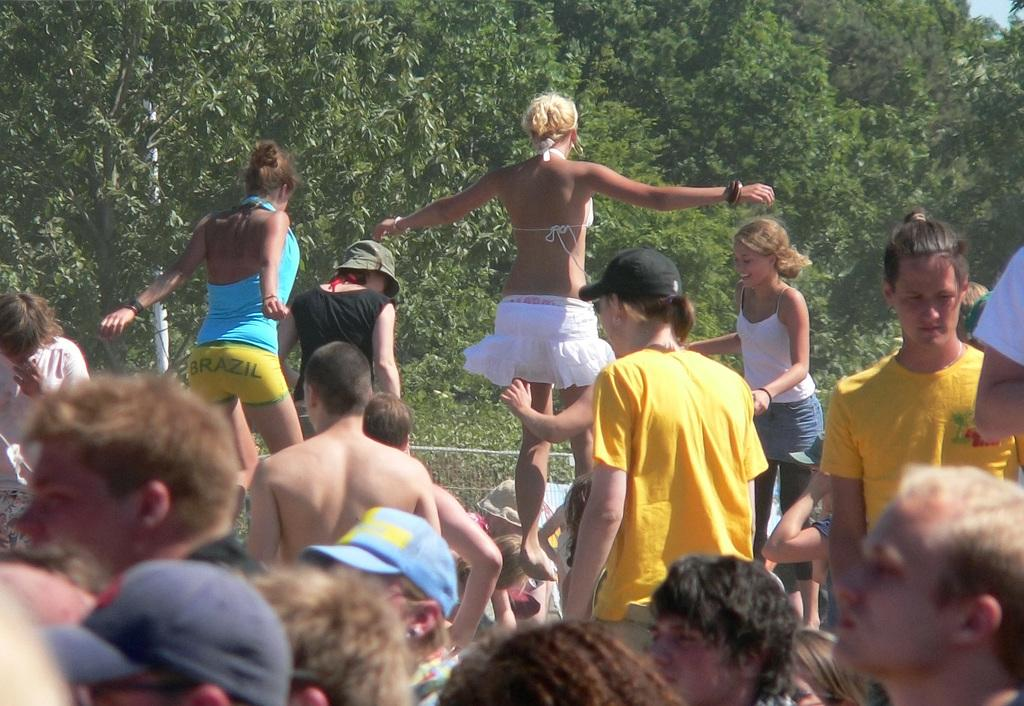How many people are in the image? There are a few persons in the image. What are two of the women doing in the image? Two women are jumping in the image. How is the woman on the right side of the image feeling? There is another woman on the right side of the image who is smiling. What can be seen in the background of the image? There are trees in the background of the image. What type of paste is being used by the women in the image? There is no paste present in the image; the women are jumping and smiling. Is the image taking place in a hospital setting? No, there is no indication of a hospital setting in the image. 